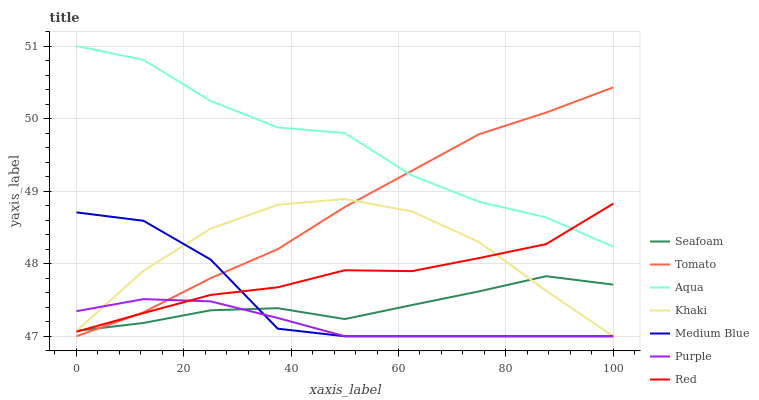Does Purple have the minimum area under the curve?
Answer yes or no. Yes. Does Aqua have the maximum area under the curve?
Answer yes or no. Yes. Does Khaki have the minimum area under the curve?
Answer yes or no. No. Does Khaki have the maximum area under the curve?
Answer yes or no. No. Is Purple the smoothest?
Answer yes or no. Yes. Is Aqua the roughest?
Answer yes or no. Yes. Is Khaki the smoothest?
Answer yes or no. No. Is Khaki the roughest?
Answer yes or no. No. Does Aqua have the lowest value?
Answer yes or no. No. Does Aqua have the highest value?
Answer yes or no. Yes. Does Khaki have the highest value?
Answer yes or no. No. Is Seafoam less than Aqua?
Answer yes or no. Yes. Is Aqua greater than Medium Blue?
Answer yes or no. Yes. Does Purple intersect Medium Blue?
Answer yes or no. Yes. Is Purple less than Medium Blue?
Answer yes or no. No. Is Purple greater than Medium Blue?
Answer yes or no. No. Does Seafoam intersect Aqua?
Answer yes or no. No. 